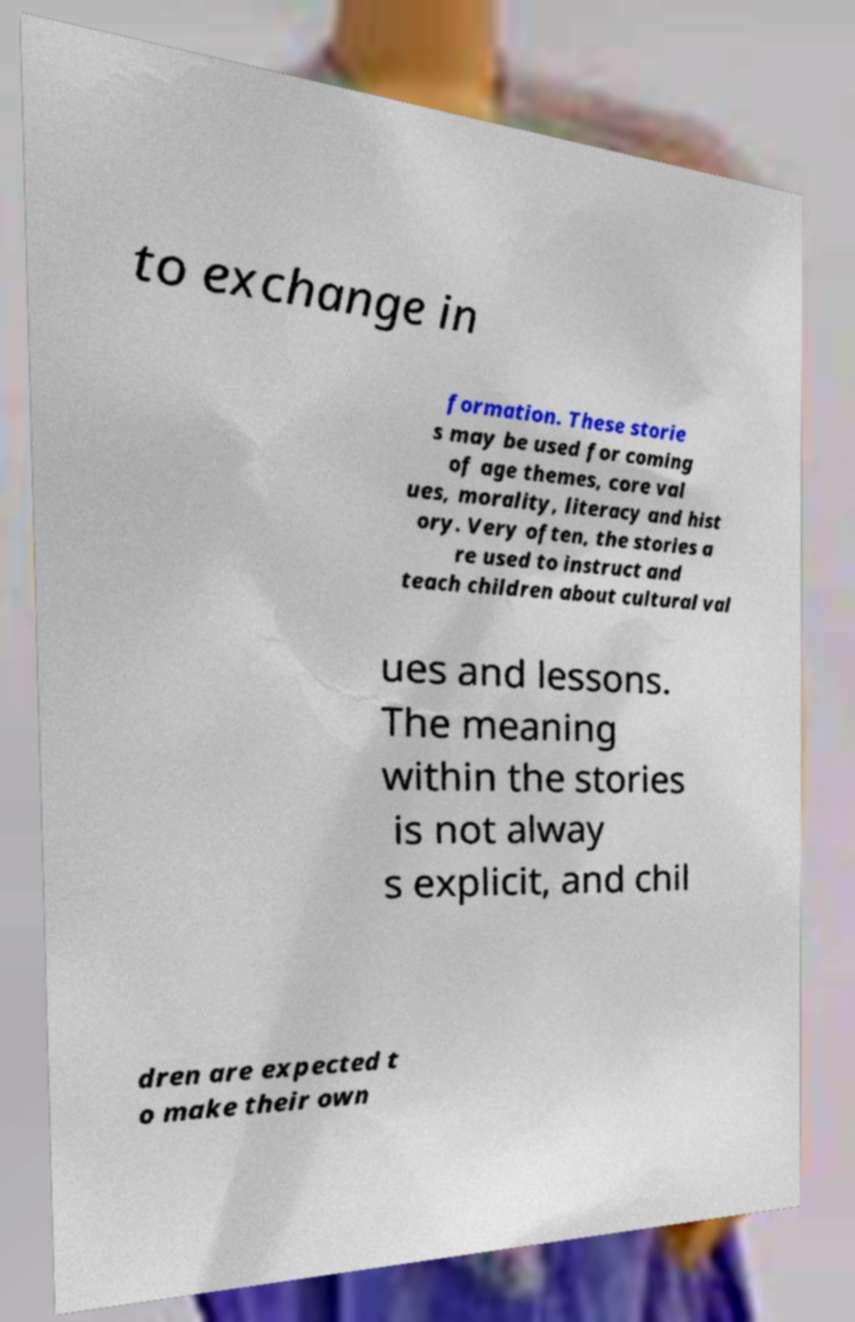For documentation purposes, I need the text within this image transcribed. Could you provide that? to exchange in formation. These storie s may be used for coming of age themes, core val ues, morality, literacy and hist ory. Very often, the stories a re used to instruct and teach children about cultural val ues and lessons. The meaning within the stories is not alway s explicit, and chil dren are expected t o make their own 